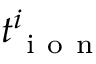<formula> <loc_0><loc_0><loc_500><loc_500>t _ { i o n } ^ { i }</formula> 